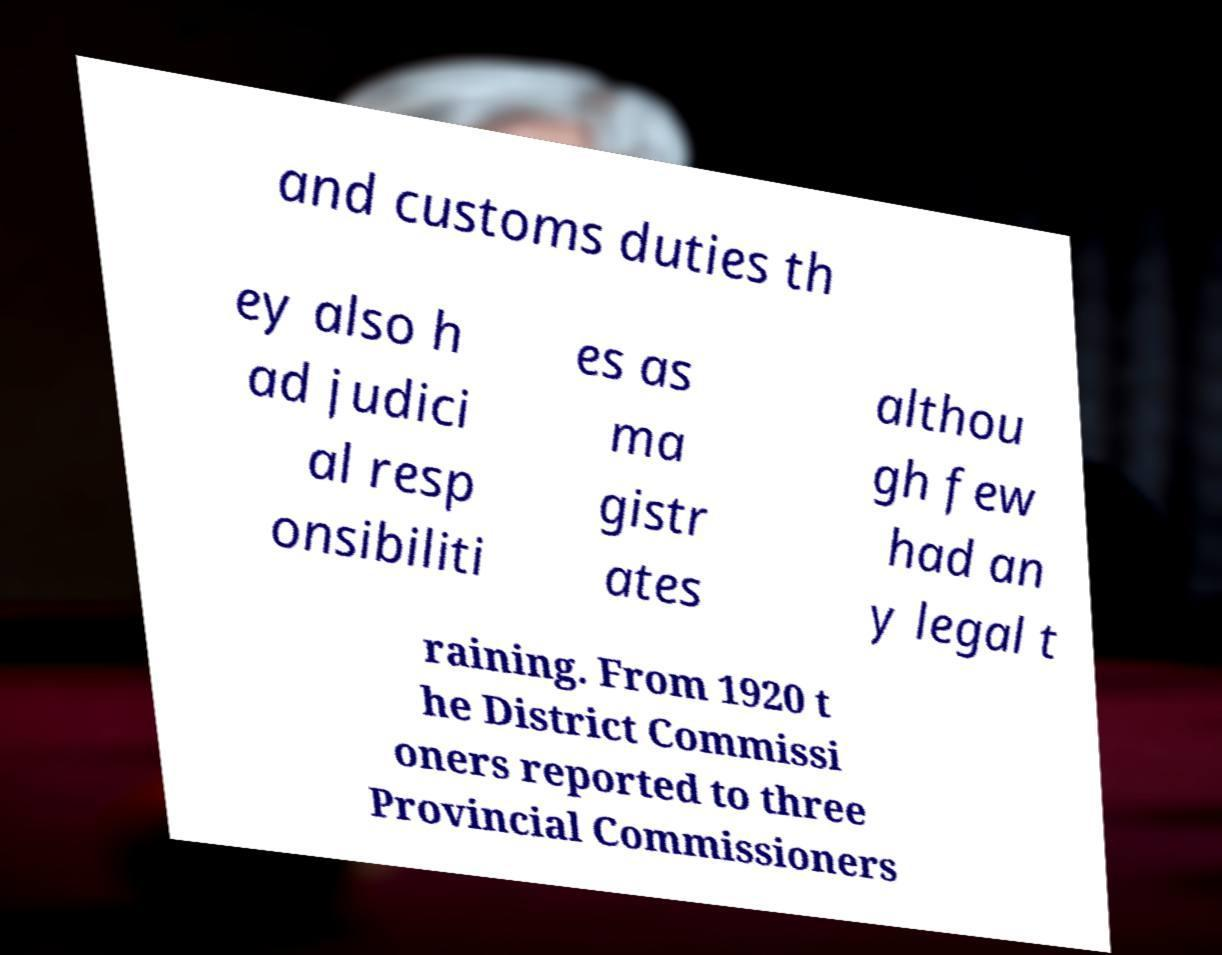For documentation purposes, I need the text within this image transcribed. Could you provide that? and customs duties th ey also h ad judici al resp onsibiliti es as ma gistr ates althou gh few had an y legal t raining. From 1920 t he District Commissi oners reported to three Provincial Commissioners 